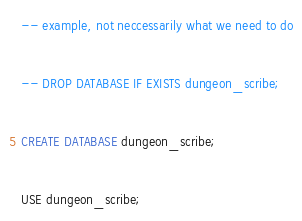Convert code to text. <code><loc_0><loc_0><loc_500><loc_500><_SQL_>-- example, not neccessarily what we need to do

-- DROP DATABASE IF EXISTS dungeon_scribe;

CREATE DATABASE dungeon_scribe;

USE dungeon_scribe;</code> 